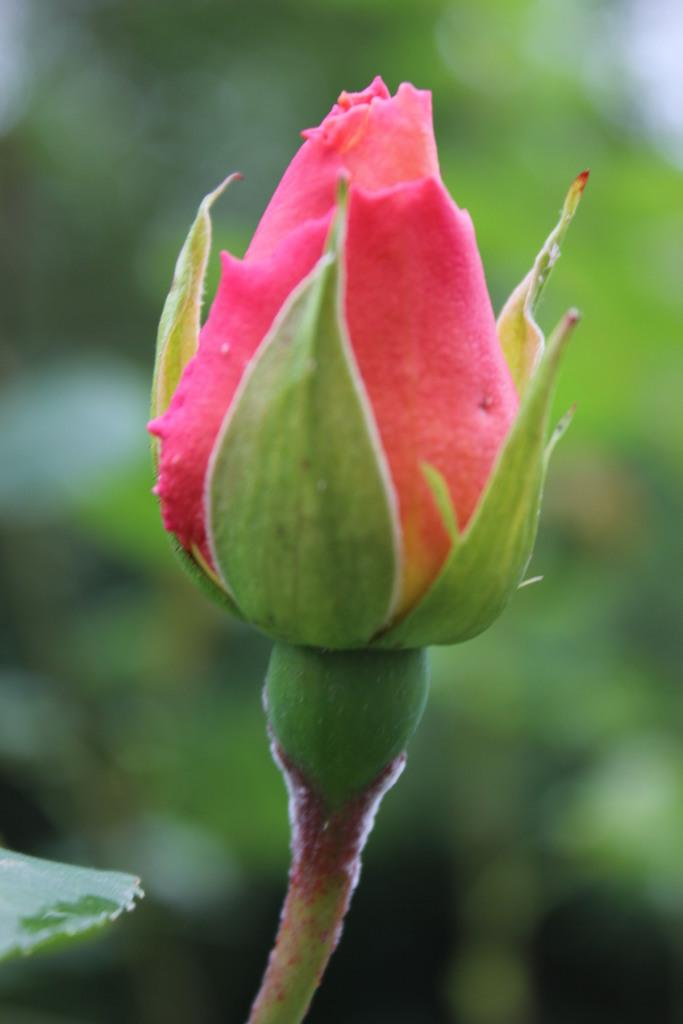What is the main subject of the image? The main subject of the image is a bud. Can you describe the background of the image? The background of the image is blurred. What type of smile can be seen on the actor's face in the image? There is no actor or smile present in the image; it features a bud with a blurred background. 